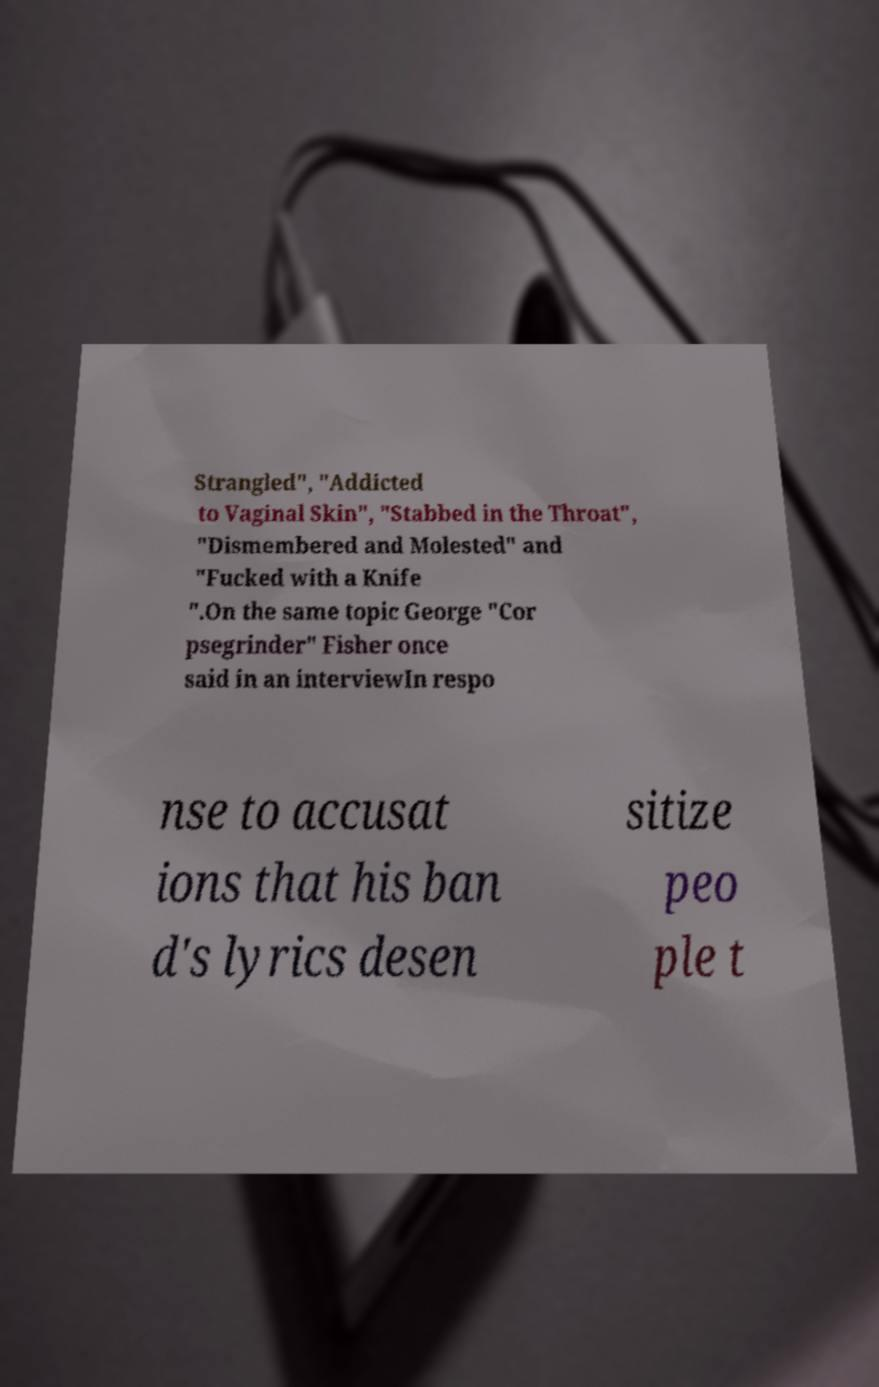Could you extract and type out the text from this image? Strangled", "Addicted to Vaginal Skin", "Stabbed in the Throat", "Dismembered and Molested" and "Fucked with a Knife ".On the same topic George "Cor psegrinder" Fisher once said in an interviewIn respo nse to accusat ions that his ban d's lyrics desen sitize peo ple t 